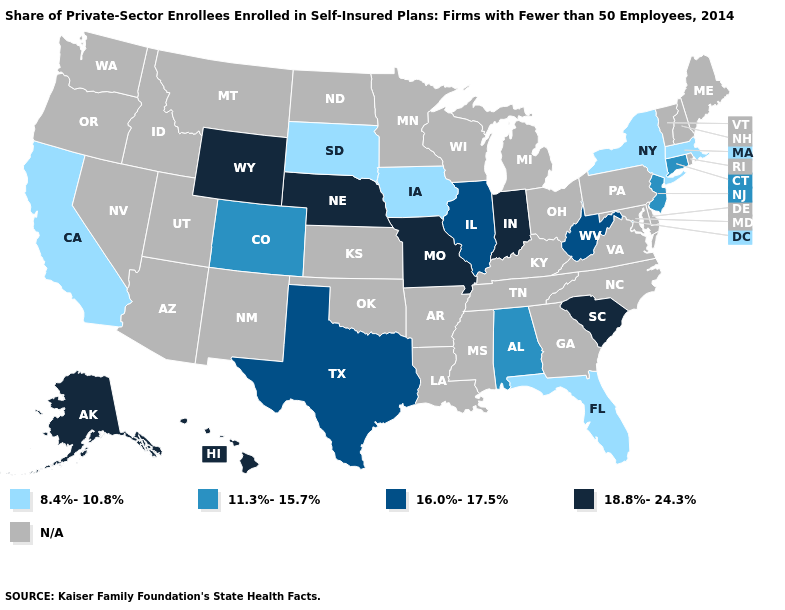What is the value of Nevada?
Quick response, please. N/A. What is the value of Florida?
Be succinct. 8.4%-10.8%. What is the highest value in states that border Florida?
Answer briefly. 11.3%-15.7%. Name the states that have a value in the range N/A?
Be succinct. Arizona, Arkansas, Delaware, Georgia, Idaho, Kansas, Kentucky, Louisiana, Maine, Maryland, Michigan, Minnesota, Mississippi, Montana, Nevada, New Hampshire, New Mexico, North Carolina, North Dakota, Ohio, Oklahoma, Oregon, Pennsylvania, Rhode Island, Tennessee, Utah, Vermont, Virginia, Washington, Wisconsin. Does Hawaii have the highest value in the USA?
Give a very brief answer. Yes. Among the states that border Wisconsin , does Illinois have the lowest value?
Answer briefly. No. What is the lowest value in states that border Rhode Island?
Keep it brief. 8.4%-10.8%. What is the value of Oklahoma?
Concise answer only. N/A. Name the states that have a value in the range 11.3%-15.7%?
Write a very short answer. Alabama, Colorado, Connecticut, New Jersey. What is the highest value in states that border Missouri?
Be succinct. 18.8%-24.3%. What is the highest value in the USA?
Give a very brief answer. 18.8%-24.3%. What is the value of California?
Write a very short answer. 8.4%-10.8%. What is the value of Arizona?
Answer briefly. N/A. How many symbols are there in the legend?
Keep it brief. 5. 